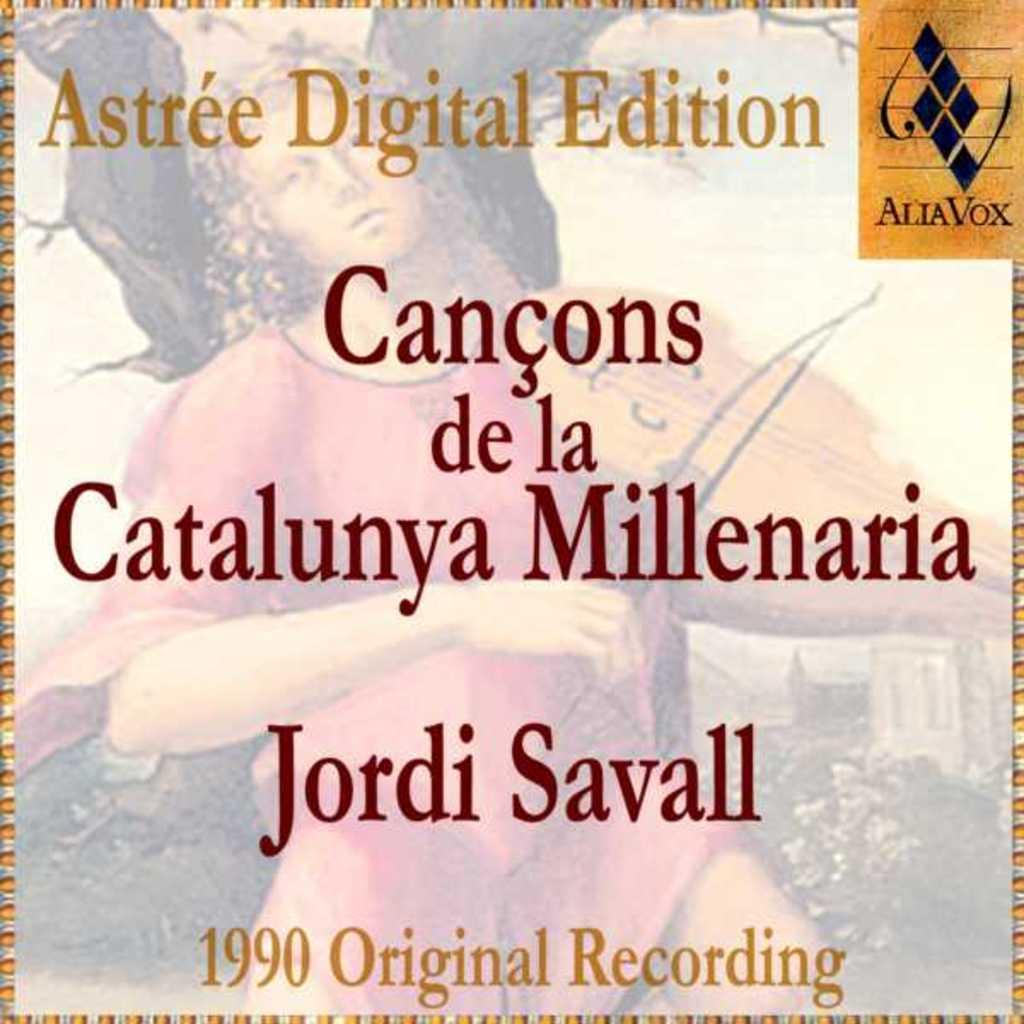<image>
Offer a succinct explanation of the picture presented. 1990 Original Recording of the Astree Digital Edition. 